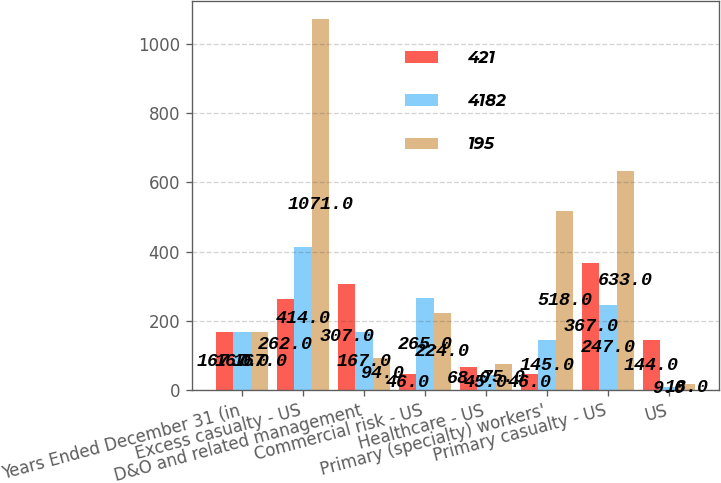Convert chart to OTSL. <chart><loc_0><loc_0><loc_500><loc_500><stacked_bar_chart><ecel><fcel>Years Ended December 31 (in<fcel>Excess casualty - US<fcel>D&O and related management<fcel>Commercial risk - US<fcel>Healthcare - US<fcel>Primary (specialty) workers'<fcel>Primary casualty - US<fcel>US<nl><fcel>421<fcel>167<fcel>262<fcel>307<fcel>46<fcel>68<fcel>46<fcel>367<fcel>144<nl><fcel>4182<fcel>167<fcel>414<fcel>167<fcel>265<fcel>45<fcel>145<fcel>247<fcel>9<nl><fcel>195<fcel>167<fcel>1071<fcel>94<fcel>224<fcel>75<fcel>518<fcel>633<fcel>18<nl></chart> 